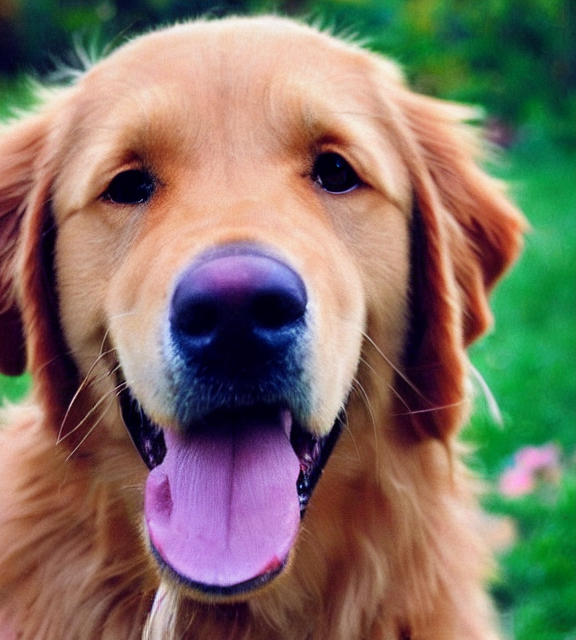Can you tell me about the environment the dog is in? The dog appears to be outdoors with greenery in the background, suggesting a park or a garden as the setting. 